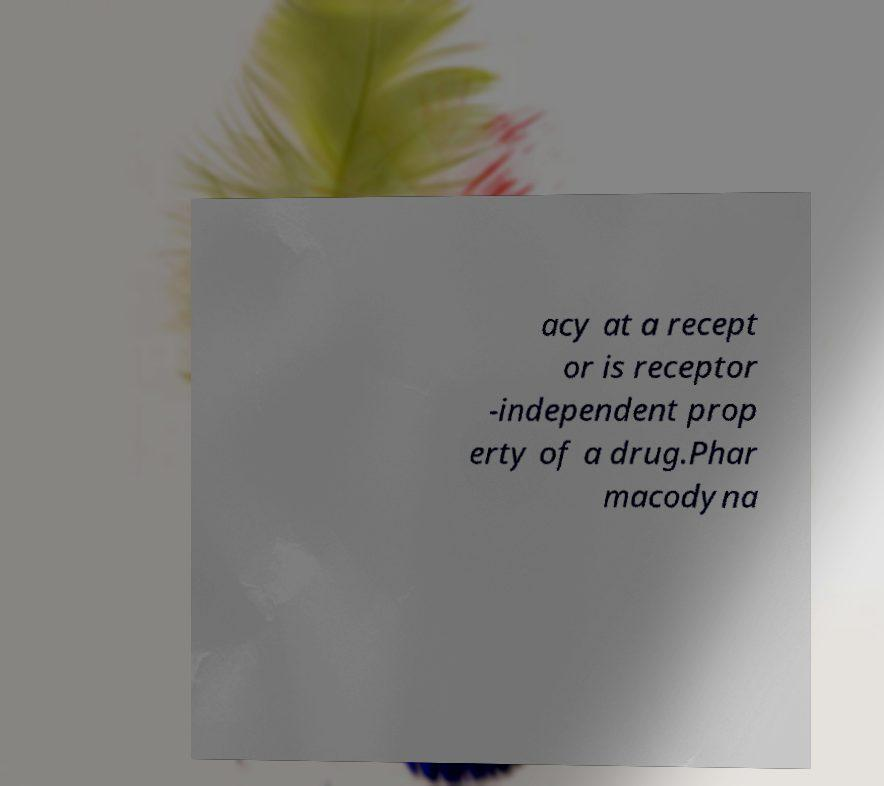Can you read and provide the text displayed in the image?This photo seems to have some interesting text. Can you extract and type it out for me? acy at a recept or is receptor -independent prop erty of a drug.Phar macodyna 